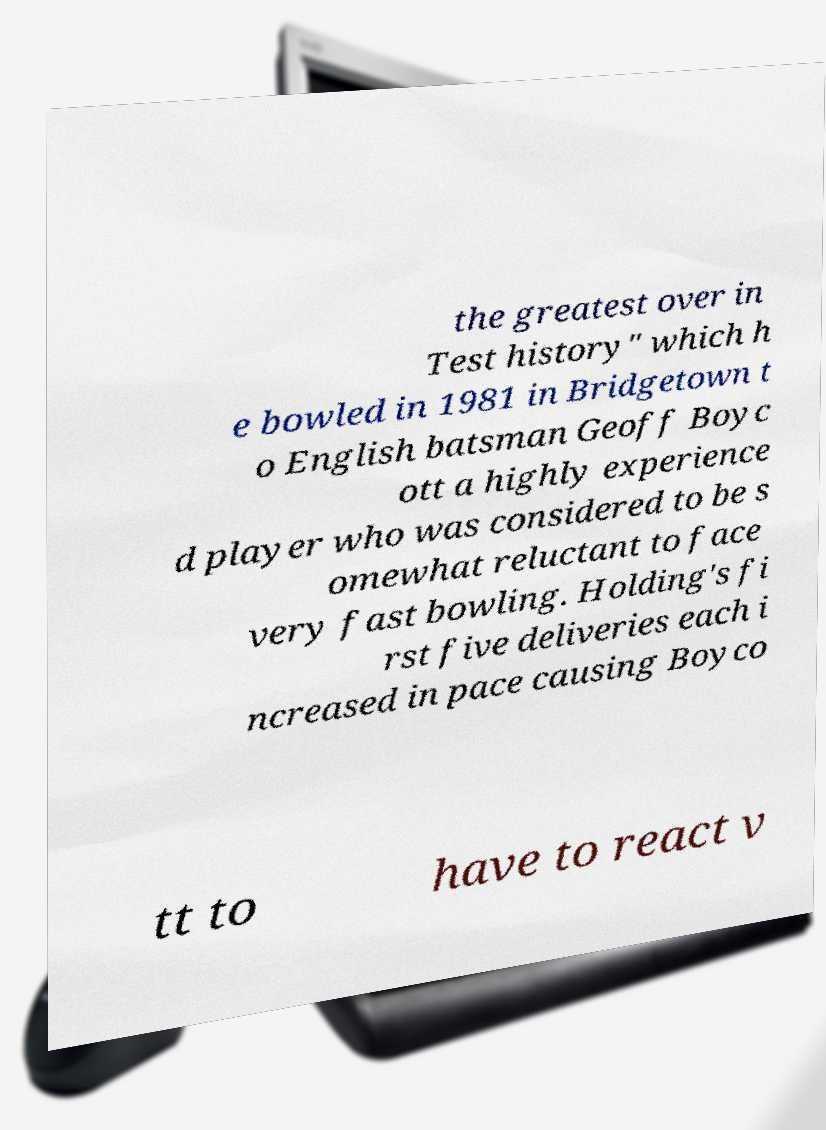Please read and relay the text visible in this image. What does it say? the greatest over in Test history" which h e bowled in 1981 in Bridgetown t o English batsman Geoff Boyc ott a highly experience d player who was considered to be s omewhat reluctant to face very fast bowling. Holding's fi rst five deliveries each i ncreased in pace causing Boyco tt to have to react v 